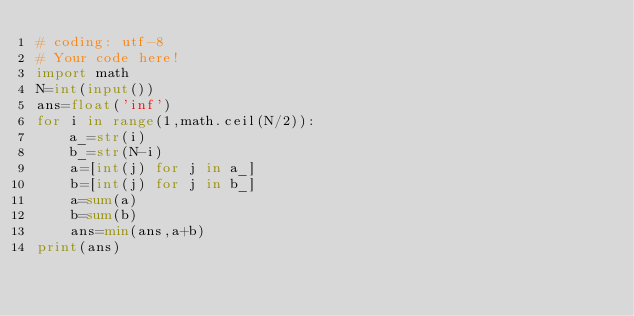<code> <loc_0><loc_0><loc_500><loc_500><_Python_># coding: utf-8
# Your code here!
import math
N=int(input())
ans=float('inf')
for i in range(1,math.ceil(N/2)):
    a_=str(i)
    b_=str(N-i)
    a=[int(j) for j in a_]
    b=[int(j) for j in b_]
    a=sum(a)
    b=sum(b)
    ans=min(ans,a+b)
print(ans)</code> 